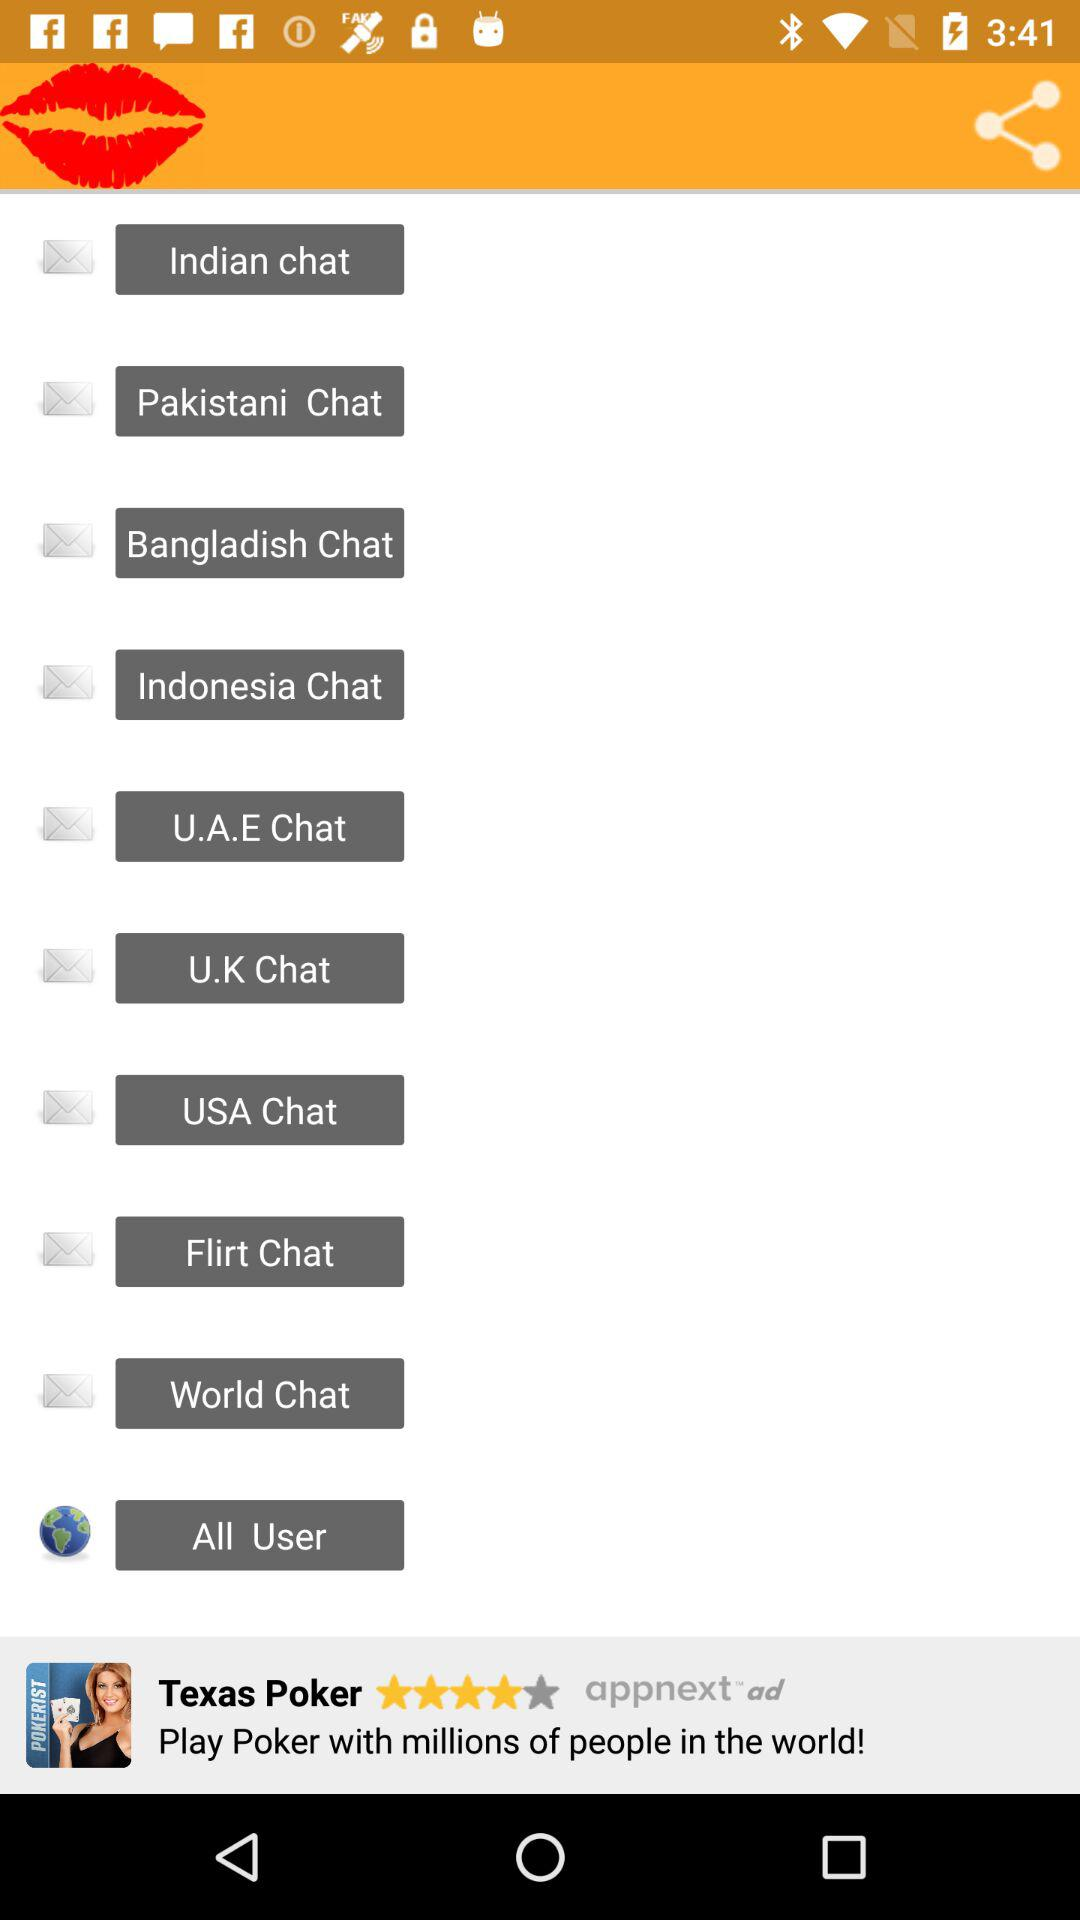How many chat options are there?
Answer the question using a single word or phrase. 10 